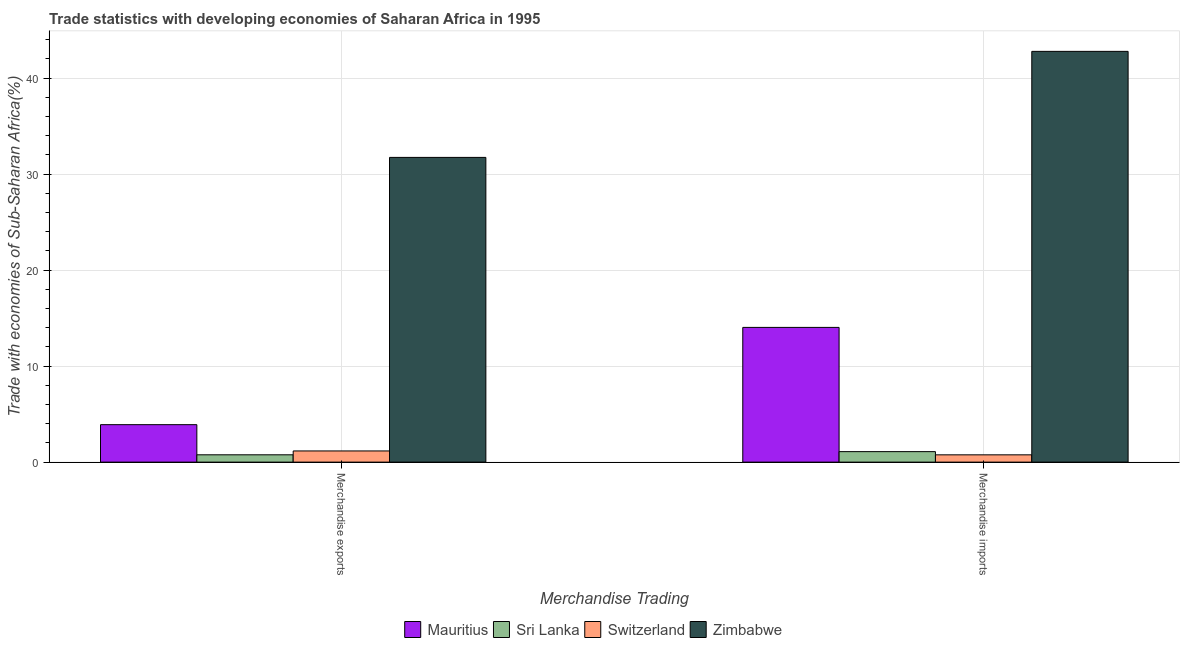How many groups of bars are there?
Ensure brevity in your answer.  2. How many bars are there on the 1st tick from the left?
Offer a very short reply. 4. How many bars are there on the 1st tick from the right?
Give a very brief answer. 4. What is the merchandise exports in Sri Lanka?
Your response must be concise. 0.76. Across all countries, what is the maximum merchandise imports?
Give a very brief answer. 42.79. Across all countries, what is the minimum merchandise exports?
Ensure brevity in your answer.  0.76. In which country was the merchandise imports maximum?
Keep it short and to the point. Zimbabwe. In which country was the merchandise imports minimum?
Your response must be concise. Switzerland. What is the total merchandise exports in the graph?
Keep it short and to the point. 37.58. What is the difference between the merchandise exports in Sri Lanka and that in Switzerland?
Give a very brief answer. -0.4. What is the difference between the merchandise imports in Mauritius and the merchandise exports in Sri Lanka?
Offer a very short reply. 13.27. What is the average merchandise imports per country?
Offer a terse response. 14.67. What is the difference between the merchandise exports and merchandise imports in Sri Lanka?
Give a very brief answer. -0.33. What is the ratio of the merchandise imports in Mauritius to that in Switzerland?
Offer a very short reply. 18.47. Is the merchandise imports in Mauritius less than that in Switzerland?
Your answer should be compact. No. In how many countries, is the merchandise imports greater than the average merchandise imports taken over all countries?
Your answer should be compact. 1. What does the 2nd bar from the left in Merchandise imports represents?
Offer a terse response. Sri Lanka. What does the 4th bar from the right in Merchandise imports represents?
Your answer should be compact. Mauritius. How many bars are there?
Keep it short and to the point. 8. What is the difference between two consecutive major ticks on the Y-axis?
Provide a short and direct response. 10. Are the values on the major ticks of Y-axis written in scientific E-notation?
Make the answer very short. No. Does the graph contain any zero values?
Make the answer very short. No. Does the graph contain grids?
Give a very brief answer. Yes. How many legend labels are there?
Offer a terse response. 4. How are the legend labels stacked?
Offer a very short reply. Horizontal. What is the title of the graph?
Offer a very short reply. Trade statistics with developing economies of Saharan Africa in 1995. What is the label or title of the X-axis?
Your answer should be very brief. Merchandise Trading. What is the label or title of the Y-axis?
Keep it short and to the point. Trade with economies of Sub-Saharan Africa(%). What is the Trade with economies of Sub-Saharan Africa(%) in Mauritius in Merchandise exports?
Your answer should be very brief. 3.9. What is the Trade with economies of Sub-Saharan Africa(%) of Sri Lanka in Merchandise exports?
Your answer should be very brief. 0.76. What is the Trade with economies of Sub-Saharan Africa(%) in Switzerland in Merchandise exports?
Offer a very short reply. 1.16. What is the Trade with economies of Sub-Saharan Africa(%) in Zimbabwe in Merchandise exports?
Your response must be concise. 31.75. What is the Trade with economies of Sub-Saharan Africa(%) in Mauritius in Merchandise imports?
Provide a short and direct response. 14.04. What is the Trade with economies of Sub-Saharan Africa(%) in Sri Lanka in Merchandise imports?
Ensure brevity in your answer.  1.09. What is the Trade with economies of Sub-Saharan Africa(%) in Switzerland in Merchandise imports?
Offer a very short reply. 0.76. What is the Trade with economies of Sub-Saharan Africa(%) of Zimbabwe in Merchandise imports?
Ensure brevity in your answer.  42.79. Across all Merchandise Trading, what is the maximum Trade with economies of Sub-Saharan Africa(%) in Mauritius?
Offer a very short reply. 14.04. Across all Merchandise Trading, what is the maximum Trade with economies of Sub-Saharan Africa(%) of Sri Lanka?
Provide a short and direct response. 1.09. Across all Merchandise Trading, what is the maximum Trade with economies of Sub-Saharan Africa(%) of Switzerland?
Provide a short and direct response. 1.16. Across all Merchandise Trading, what is the maximum Trade with economies of Sub-Saharan Africa(%) of Zimbabwe?
Make the answer very short. 42.79. Across all Merchandise Trading, what is the minimum Trade with economies of Sub-Saharan Africa(%) in Mauritius?
Give a very brief answer. 3.9. Across all Merchandise Trading, what is the minimum Trade with economies of Sub-Saharan Africa(%) of Sri Lanka?
Ensure brevity in your answer.  0.76. Across all Merchandise Trading, what is the minimum Trade with economies of Sub-Saharan Africa(%) of Switzerland?
Give a very brief answer. 0.76. Across all Merchandise Trading, what is the minimum Trade with economies of Sub-Saharan Africa(%) of Zimbabwe?
Give a very brief answer. 31.75. What is the total Trade with economies of Sub-Saharan Africa(%) in Mauritius in the graph?
Make the answer very short. 17.94. What is the total Trade with economies of Sub-Saharan Africa(%) of Sri Lanka in the graph?
Give a very brief answer. 1.86. What is the total Trade with economies of Sub-Saharan Africa(%) in Switzerland in the graph?
Offer a terse response. 1.92. What is the total Trade with economies of Sub-Saharan Africa(%) of Zimbabwe in the graph?
Give a very brief answer. 74.54. What is the difference between the Trade with economies of Sub-Saharan Africa(%) in Mauritius in Merchandise exports and that in Merchandise imports?
Provide a succinct answer. -10.13. What is the difference between the Trade with economies of Sub-Saharan Africa(%) of Sri Lanka in Merchandise exports and that in Merchandise imports?
Your answer should be very brief. -0.33. What is the difference between the Trade with economies of Sub-Saharan Africa(%) in Switzerland in Merchandise exports and that in Merchandise imports?
Provide a short and direct response. 0.4. What is the difference between the Trade with economies of Sub-Saharan Africa(%) of Zimbabwe in Merchandise exports and that in Merchandise imports?
Make the answer very short. -11.05. What is the difference between the Trade with economies of Sub-Saharan Africa(%) of Mauritius in Merchandise exports and the Trade with economies of Sub-Saharan Africa(%) of Sri Lanka in Merchandise imports?
Provide a succinct answer. 2.81. What is the difference between the Trade with economies of Sub-Saharan Africa(%) of Mauritius in Merchandise exports and the Trade with economies of Sub-Saharan Africa(%) of Switzerland in Merchandise imports?
Ensure brevity in your answer.  3.14. What is the difference between the Trade with economies of Sub-Saharan Africa(%) of Mauritius in Merchandise exports and the Trade with economies of Sub-Saharan Africa(%) of Zimbabwe in Merchandise imports?
Your answer should be very brief. -38.89. What is the difference between the Trade with economies of Sub-Saharan Africa(%) of Sri Lanka in Merchandise exports and the Trade with economies of Sub-Saharan Africa(%) of Switzerland in Merchandise imports?
Keep it short and to the point. 0. What is the difference between the Trade with economies of Sub-Saharan Africa(%) in Sri Lanka in Merchandise exports and the Trade with economies of Sub-Saharan Africa(%) in Zimbabwe in Merchandise imports?
Your response must be concise. -42.03. What is the difference between the Trade with economies of Sub-Saharan Africa(%) of Switzerland in Merchandise exports and the Trade with economies of Sub-Saharan Africa(%) of Zimbabwe in Merchandise imports?
Provide a succinct answer. -41.63. What is the average Trade with economies of Sub-Saharan Africa(%) of Mauritius per Merchandise Trading?
Give a very brief answer. 8.97. What is the average Trade with economies of Sub-Saharan Africa(%) in Sri Lanka per Merchandise Trading?
Provide a short and direct response. 0.93. What is the average Trade with economies of Sub-Saharan Africa(%) of Switzerland per Merchandise Trading?
Offer a very short reply. 0.96. What is the average Trade with economies of Sub-Saharan Africa(%) of Zimbabwe per Merchandise Trading?
Ensure brevity in your answer.  37.27. What is the difference between the Trade with economies of Sub-Saharan Africa(%) in Mauritius and Trade with economies of Sub-Saharan Africa(%) in Sri Lanka in Merchandise exports?
Your response must be concise. 3.14. What is the difference between the Trade with economies of Sub-Saharan Africa(%) in Mauritius and Trade with economies of Sub-Saharan Africa(%) in Switzerland in Merchandise exports?
Offer a terse response. 2.74. What is the difference between the Trade with economies of Sub-Saharan Africa(%) of Mauritius and Trade with economies of Sub-Saharan Africa(%) of Zimbabwe in Merchandise exports?
Give a very brief answer. -27.84. What is the difference between the Trade with economies of Sub-Saharan Africa(%) in Sri Lanka and Trade with economies of Sub-Saharan Africa(%) in Switzerland in Merchandise exports?
Offer a very short reply. -0.4. What is the difference between the Trade with economies of Sub-Saharan Africa(%) of Sri Lanka and Trade with economies of Sub-Saharan Africa(%) of Zimbabwe in Merchandise exports?
Offer a very short reply. -30.98. What is the difference between the Trade with economies of Sub-Saharan Africa(%) in Switzerland and Trade with economies of Sub-Saharan Africa(%) in Zimbabwe in Merchandise exports?
Your answer should be compact. -30.58. What is the difference between the Trade with economies of Sub-Saharan Africa(%) in Mauritius and Trade with economies of Sub-Saharan Africa(%) in Sri Lanka in Merchandise imports?
Ensure brevity in your answer.  12.94. What is the difference between the Trade with economies of Sub-Saharan Africa(%) in Mauritius and Trade with economies of Sub-Saharan Africa(%) in Switzerland in Merchandise imports?
Offer a terse response. 13.28. What is the difference between the Trade with economies of Sub-Saharan Africa(%) of Mauritius and Trade with economies of Sub-Saharan Africa(%) of Zimbabwe in Merchandise imports?
Offer a terse response. -28.76. What is the difference between the Trade with economies of Sub-Saharan Africa(%) in Sri Lanka and Trade with economies of Sub-Saharan Africa(%) in Switzerland in Merchandise imports?
Your response must be concise. 0.33. What is the difference between the Trade with economies of Sub-Saharan Africa(%) of Sri Lanka and Trade with economies of Sub-Saharan Africa(%) of Zimbabwe in Merchandise imports?
Offer a very short reply. -41.7. What is the difference between the Trade with economies of Sub-Saharan Africa(%) in Switzerland and Trade with economies of Sub-Saharan Africa(%) in Zimbabwe in Merchandise imports?
Give a very brief answer. -42.03. What is the ratio of the Trade with economies of Sub-Saharan Africa(%) of Mauritius in Merchandise exports to that in Merchandise imports?
Your answer should be compact. 0.28. What is the ratio of the Trade with economies of Sub-Saharan Africa(%) of Sri Lanka in Merchandise exports to that in Merchandise imports?
Give a very brief answer. 0.7. What is the ratio of the Trade with economies of Sub-Saharan Africa(%) of Switzerland in Merchandise exports to that in Merchandise imports?
Your answer should be compact. 1.53. What is the ratio of the Trade with economies of Sub-Saharan Africa(%) of Zimbabwe in Merchandise exports to that in Merchandise imports?
Offer a very short reply. 0.74. What is the difference between the highest and the second highest Trade with economies of Sub-Saharan Africa(%) in Mauritius?
Your answer should be very brief. 10.13. What is the difference between the highest and the second highest Trade with economies of Sub-Saharan Africa(%) of Sri Lanka?
Provide a succinct answer. 0.33. What is the difference between the highest and the second highest Trade with economies of Sub-Saharan Africa(%) of Switzerland?
Offer a terse response. 0.4. What is the difference between the highest and the second highest Trade with economies of Sub-Saharan Africa(%) in Zimbabwe?
Offer a very short reply. 11.05. What is the difference between the highest and the lowest Trade with economies of Sub-Saharan Africa(%) in Mauritius?
Provide a short and direct response. 10.13. What is the difference between the highest and the lowest Trade with economies of Sub-Saharan Africa(%) in Sri Lanka?
Provide a short and direct response. 0.33. What is the difference between the highest and the lowest Trade with economies of Sub-Saharan Africa(%) of Switzerland?
Keep it short and to the point. 0.4. What is the difference between the highest and the lowest Trade with economies of Sub-Saharan Africa(%) in Zimbabwe?
Provide a succinct answer. 11.05. 